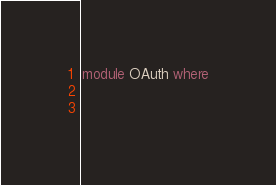<code> <loc_0><loc_0><loc_500><loc_500><_Haskell_>module OAuth where

    </code> 